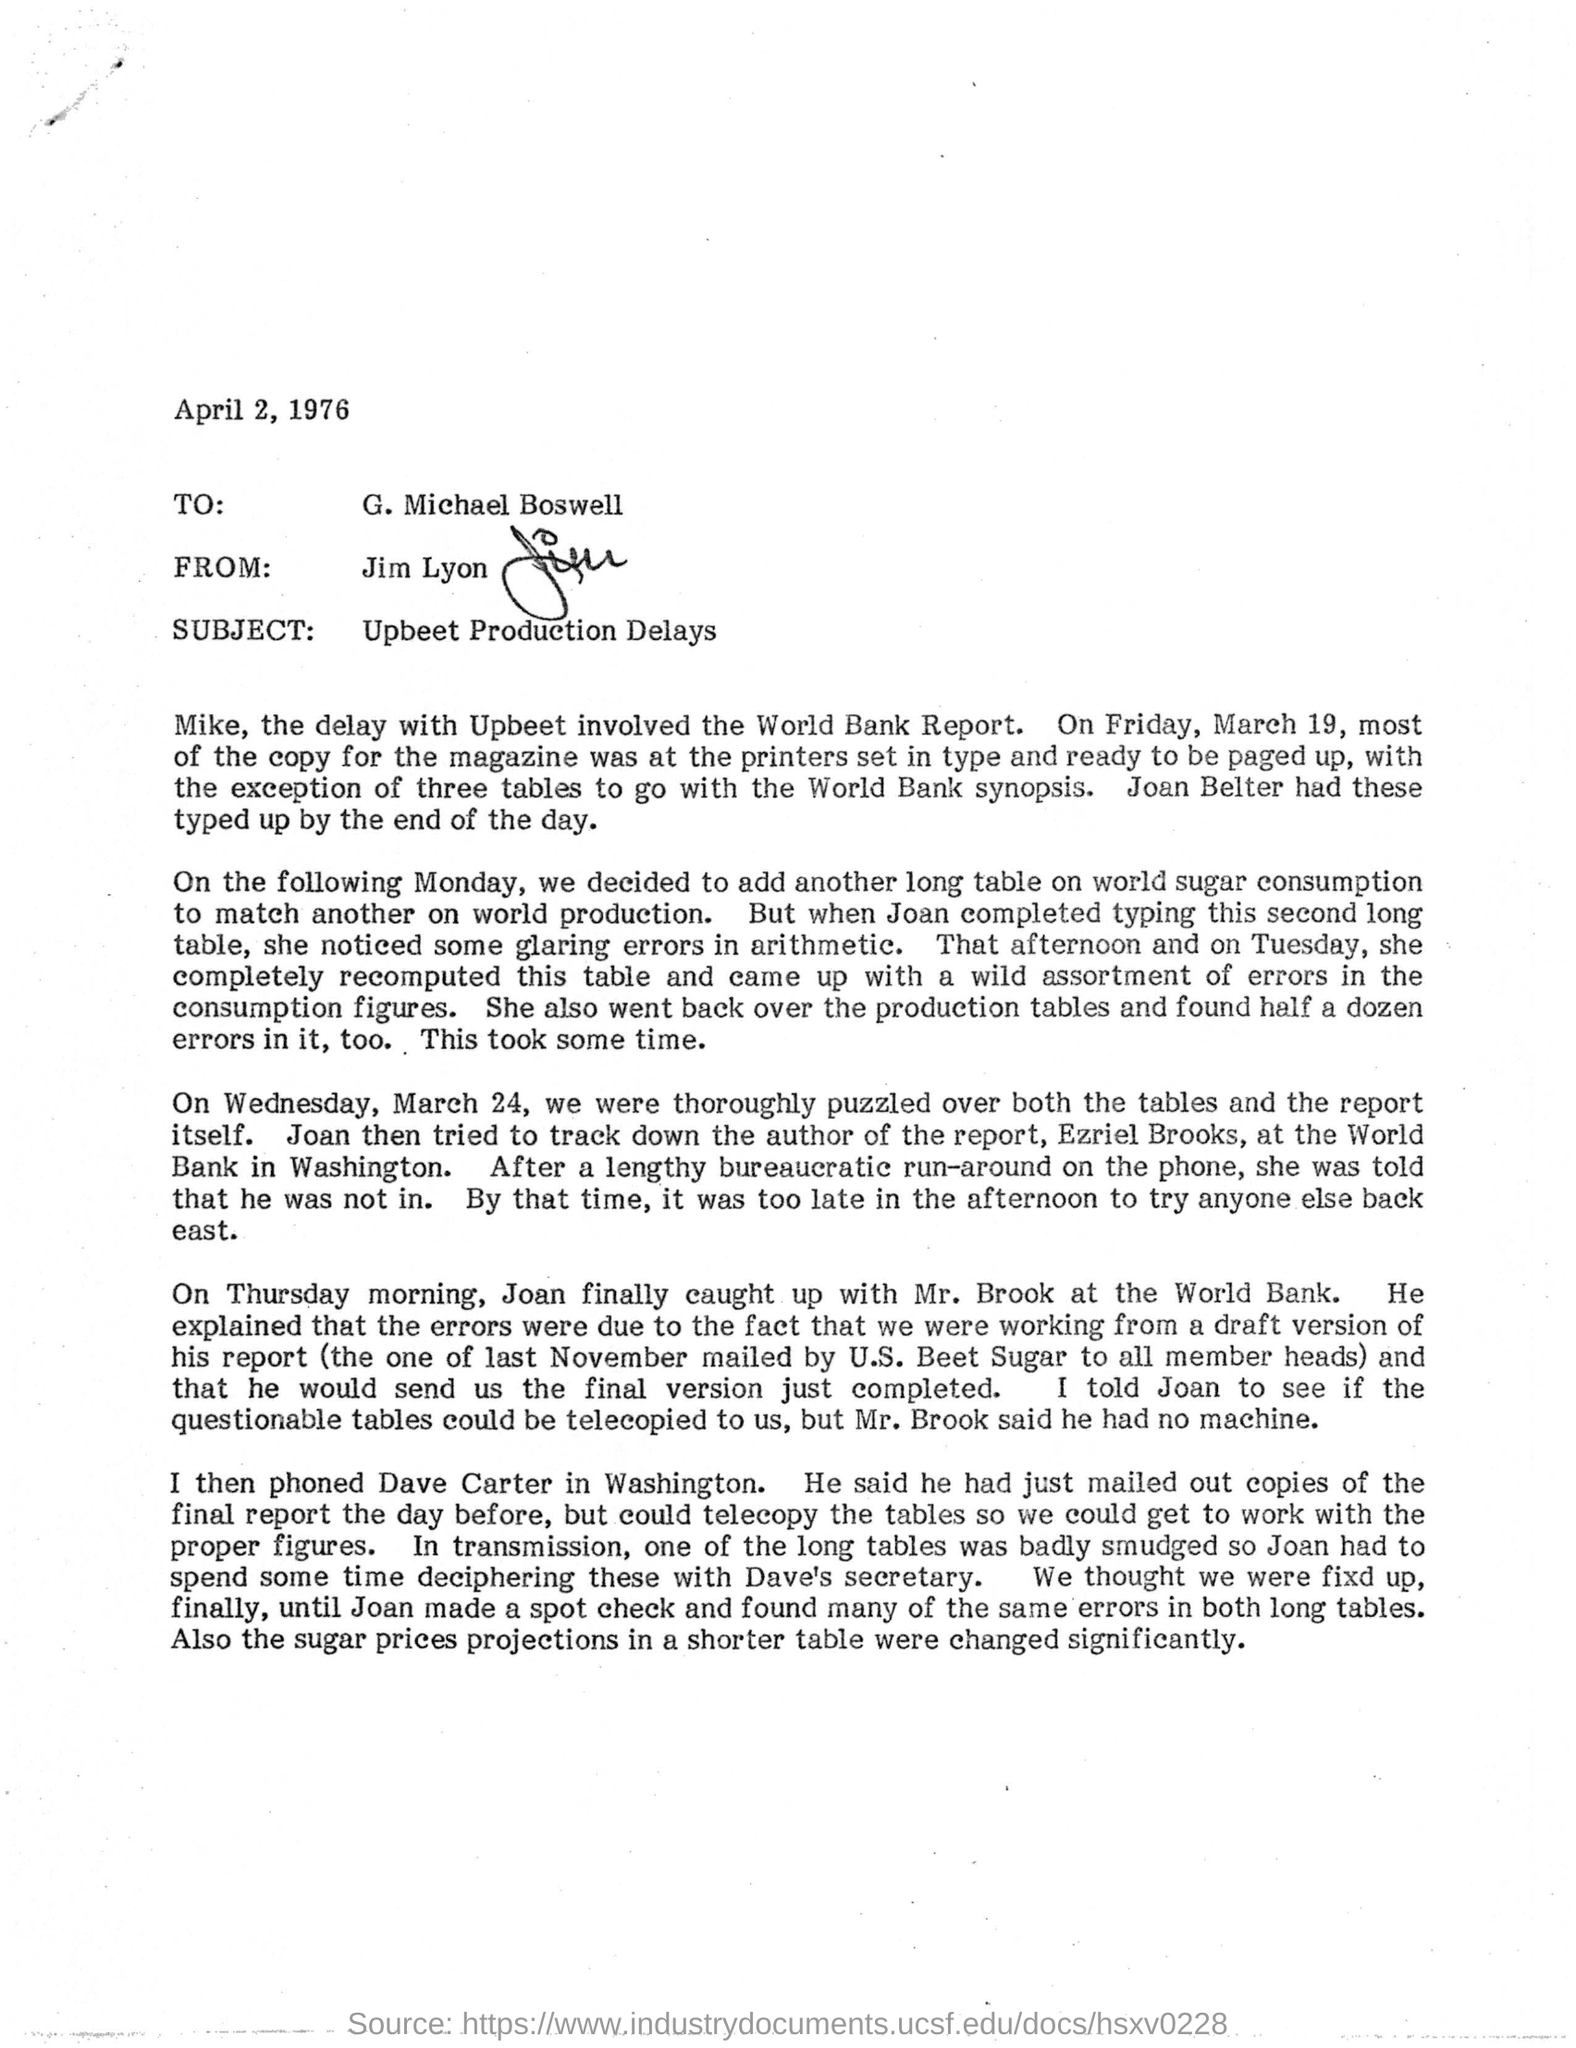To Whom is this letter addressed to?
 G. Michael Boswell 